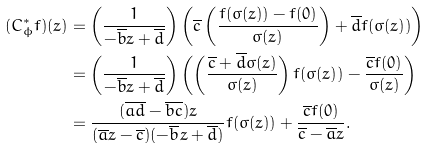<formula> <loc_0><loc_0><loc_500><loc_500>( C _ { \phi } ^ { \ast } f ) ( z ) & = \left ( \frac { 1 } { - \overline { b } z + \overline { d } } \right ) \left ( \overline { c } \left ( \frac { f ( \sigma ( z ) ) - f ( 0 ) } { \sigma ( z ) } \right ) + \overline { d } f ( \sigma ( z ) ) \right ) \\ & = \left ( \frac { 1 } { - \overline { b } z + \overline { d } } \right ) \left ( \left ( \frac { \overline { c } + \overline { d } \sigma ( z ) } { \sigma ( z ) } \right ) f ( \sigma ( z ) ) - \frac { \overline { c } f ( 0 ) } { \sigma ( z ) } \right ) \\ & = \frac { ( \overline { a d } - \overline { b c } ) z } { ( \overline { a } z - \overline { c } ) ( - \overline { b } z + \overline { d } ) } f ( \sigma ( z ) ) + \frac { \overline { c } f ( 0 ) } { \overline { c } - \overline { a } z } \text {.}</formula> 